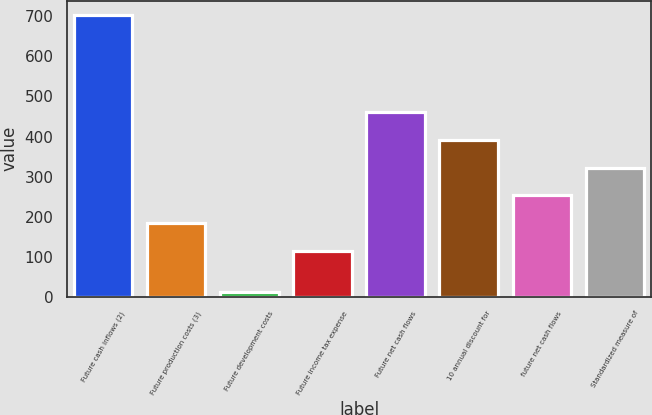Convert chart. <chart><loc_0><loc_0><loc_500><loc_500><bar_chart><fcel>Future cash inflows (2)<fcel>Future production costs (3)<fcel>Future development costs<fcel>Future income tax expense<fcel>Future net cash flows<fcel>10 annual discount for<fcel>future net cash flows<fcel>Standardized measure of<nl><fcel>704<fcel>184.2<fcel>12<fcel>115<fcel>461<fcel>391.8<fcel>253.4<fcel>322.6<nl></chart> 